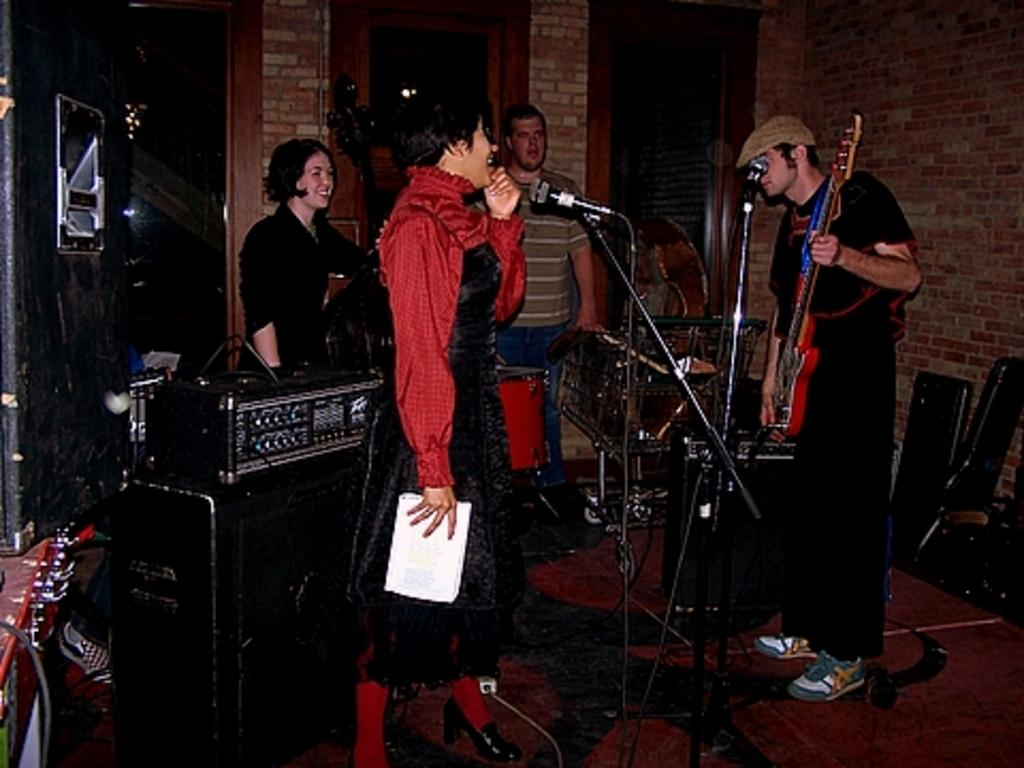What are the people in the image doing? The people in the image are standing. What object is a person holding in the image? A person is holding a guitar in the image. What can be seen on the wall in the background? The wall in the background has red color bricks. What type of invention is being demonstrated by the person holding the guitar in the image? There is no invention being demonstrated in the image; a person is simply holding a guitar. Can you see any animals in the image? No, there are no animals present in the image. 